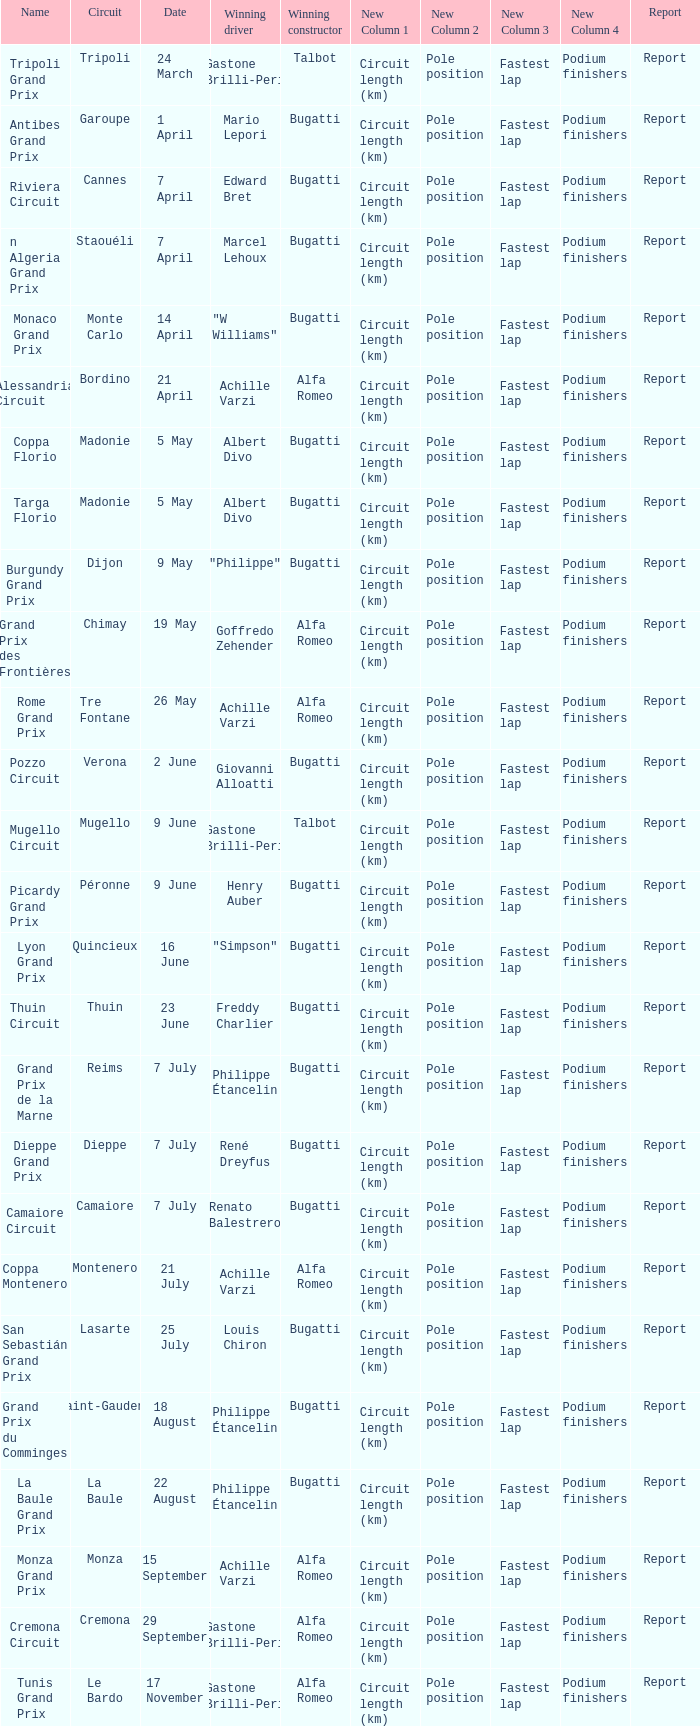What Name has a Winning constructor of bugatti, and a Winning driver of louis chiron? San Sebastián Grand Prix. 